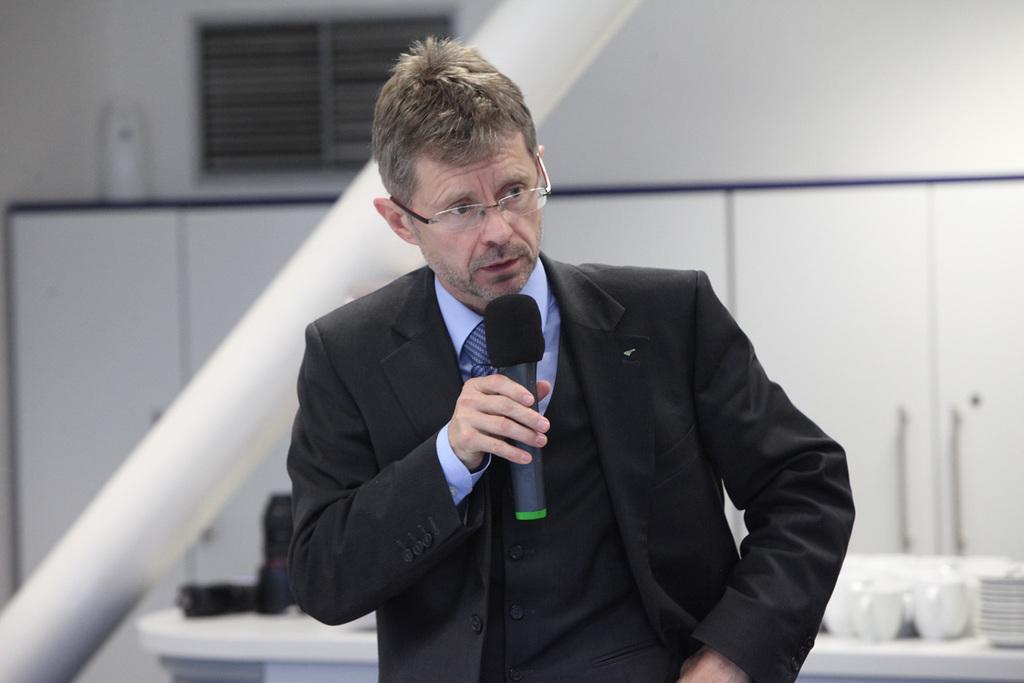In one or two sentences, can you explain what this image depicts? In this image we can see a person wearing specs and he is holding a mic. In the back there is a table with jugs, plates and few other items. Also there is a pipe. In the background we can see shelves. Also there is a wall with window ventilation. 